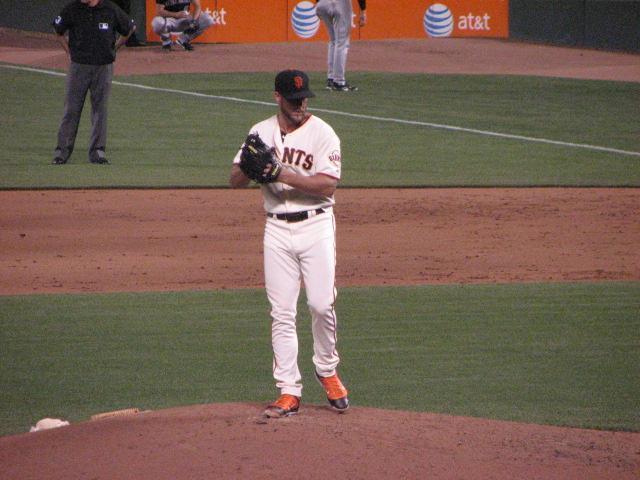How many people are there?
Give a very brief answer. 4. 